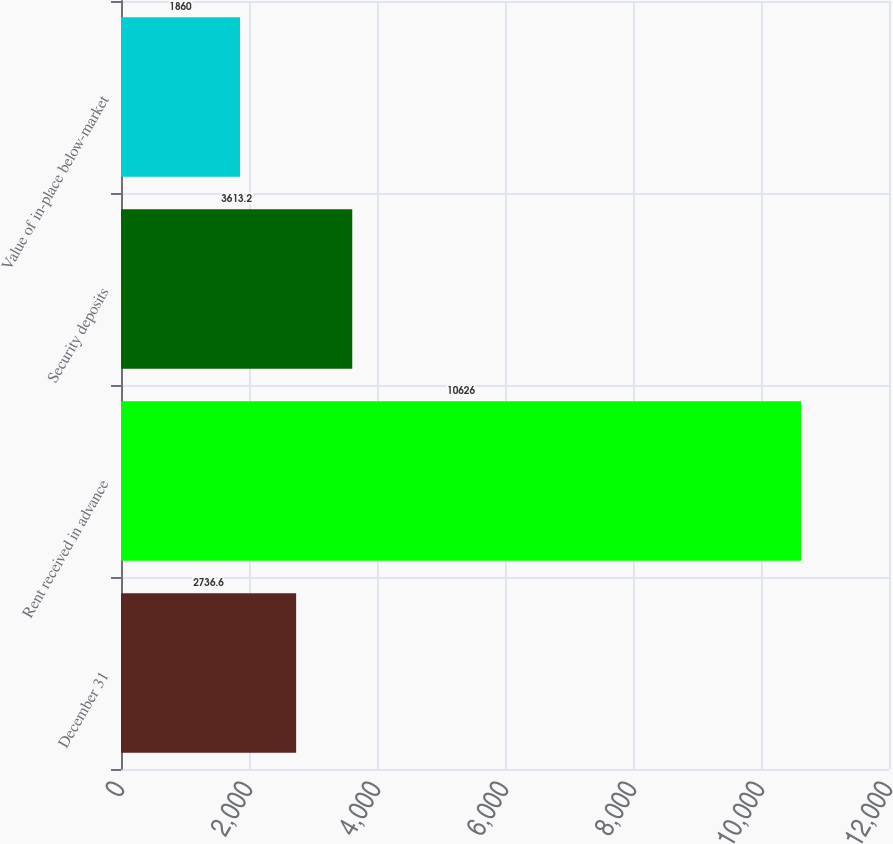Convert chart to OTSL. <chart><loc_0><loc_0><loc_500><loc_500><bar_chart><fcel>December 31<fcel>Rent received in advance<fcel>Security deposits<fcel>Value of in-place below-market<nl><fcel>2736.6<fcel>10626<fcel>3613.2<fcel>1860<nl></chart> 